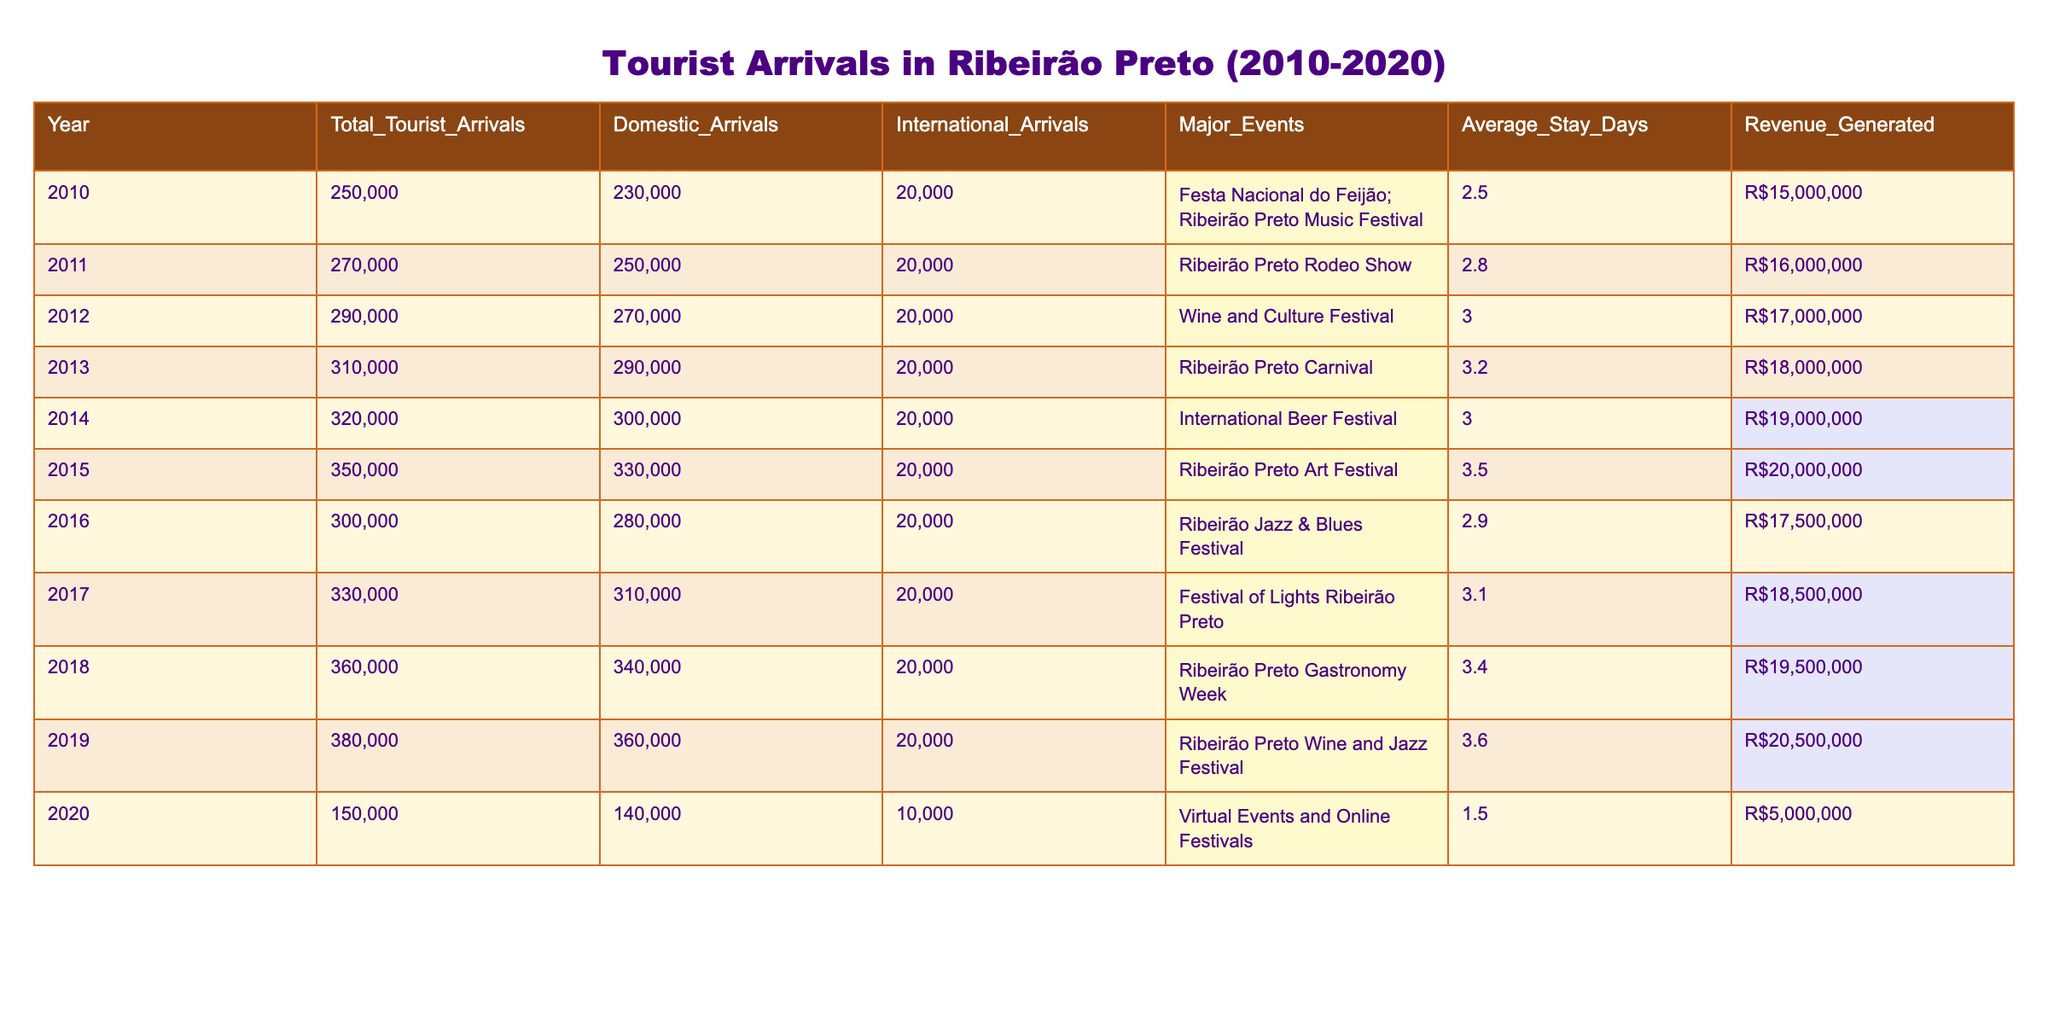What was the total number of tourist arrivals in Ribeirão Preto in 2013? In the table, I look for the row corresponding to the year 2013 and see that the value under "Total_Tourist_Arrivals" is 310,000.
Answer: 310,000 Which year had the highest revenue generated from tourist arrivals? I check the "Revenue_Generated" column and see that 2019 has the highest value, which is R$20,500,000.
Answer: R$20,500,000 How many domestic arrivals were recorded in 2015? I refer to the "Domestic_Arrivals" column for the year 2015, where the value is 330,000.
Answer: 330,000 What was the average stay in days across all years? I sum the "Average_Stay_Days" values for all the years (2.5 + 2.8 + 3.0 + 3.2 + 3.0 + 3.5 + 2.9 + 3.1 + 3.4 + 3.6) = 31.0 days, and then divide by the number of years (10) to find the average: 31.0 / 10 = 3.1.
Answer: 3.1 Was there an increase in total tourist arrivals from 2010 to 2019? I compare the values in the "Total_Tourist_Arrivals" column for 2010 (250,000) and 2019 (380,000). Since 380,000 is greater than 250,000, there was an increase.
Answer: Yes What is the total number of international arrivals in the years 2010 to 2014? I add the values of "International_Arrivals" for those years: (20,000 + 20,000 + 20,000 + 20,000 + 20,000) = 100,000.
Answer: 100,000 Which year saw the lowest total tourist arrivals and how many were there? The year 2020 has the lowest total tourist arrivals with a value of 150,000.
Answer: 150,000 What percentage of total tourist arrivals in 2018 were domestic? The total tourist arrivals in 2018 are 360,000, and the domestic arrivals are 340,000. To find the percentage, I compute (340,000 / 360,000) * 100 = 94.44%.
Answer: 94.44% How many major events were recorded in the data from 2010 to 2020? I count the number of unique events listed in the "Major_Events" column from 2010 to 2020, which totals 11 events.
Answer: 11 Was the average stay longer in 2019 or 2020? I check the "Average_Stay_Days" for both years: 2019 has 3.6 days while 2020 has 1.5 days. Since 3.6 is greater than 1.5, the average stay was longer in 2019.
Answer: 2019 What was the difference in tourist arrivals between 2014 and 2016? I subtract the total tourist arrivals of 2016 (300,000) from 2014 (320,000): 320,000 - 300,000 = 20,000.
Answer: 20,000 